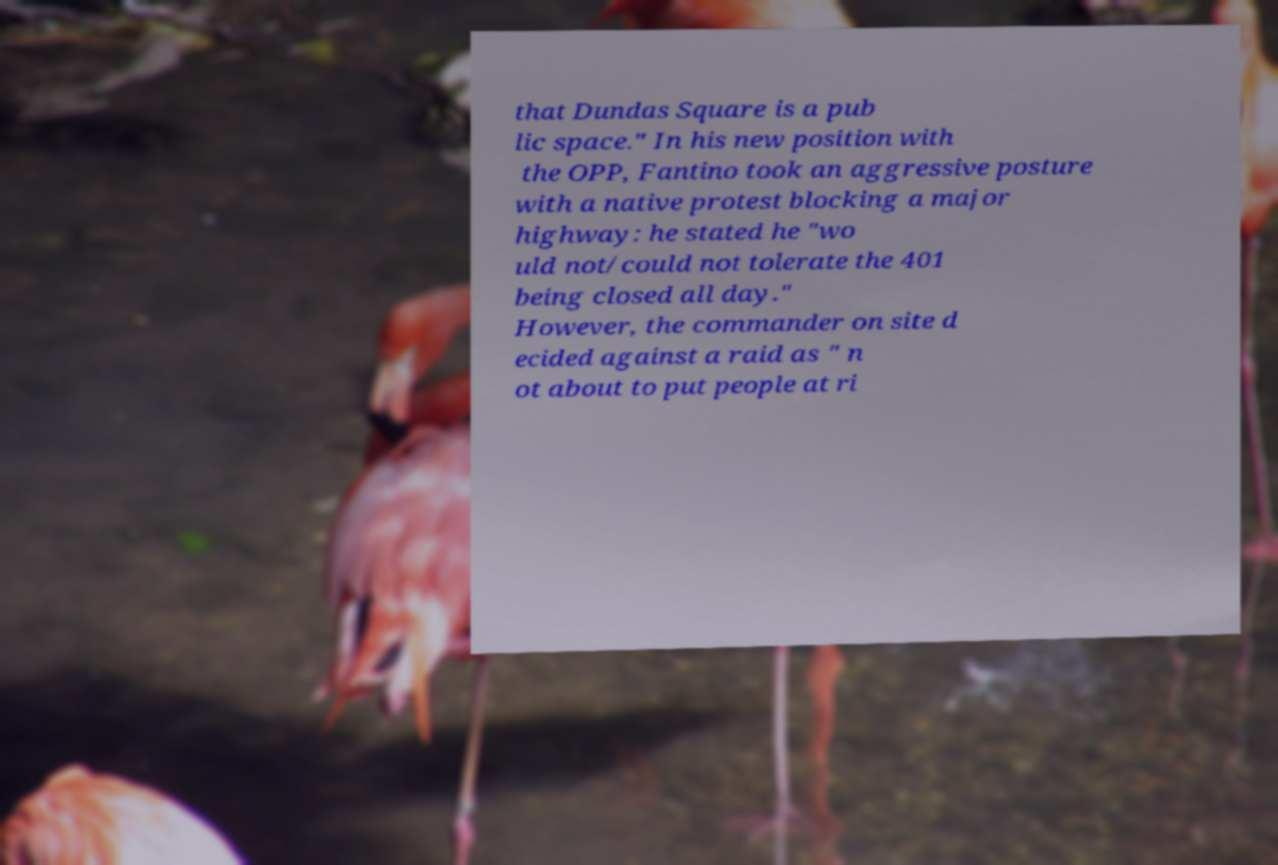Can you accurately transcribe the text from the provided image for me? that Dundas Square is a pub lic space." In his new position with the OPP, Fantino took an aggressive posture with a native protest blocking a major highway: he stated he "wo uld not/could not tolerate the 401 being closed all day." However, the commander on site d ecided against a raid as " n ot about to put people at ri 